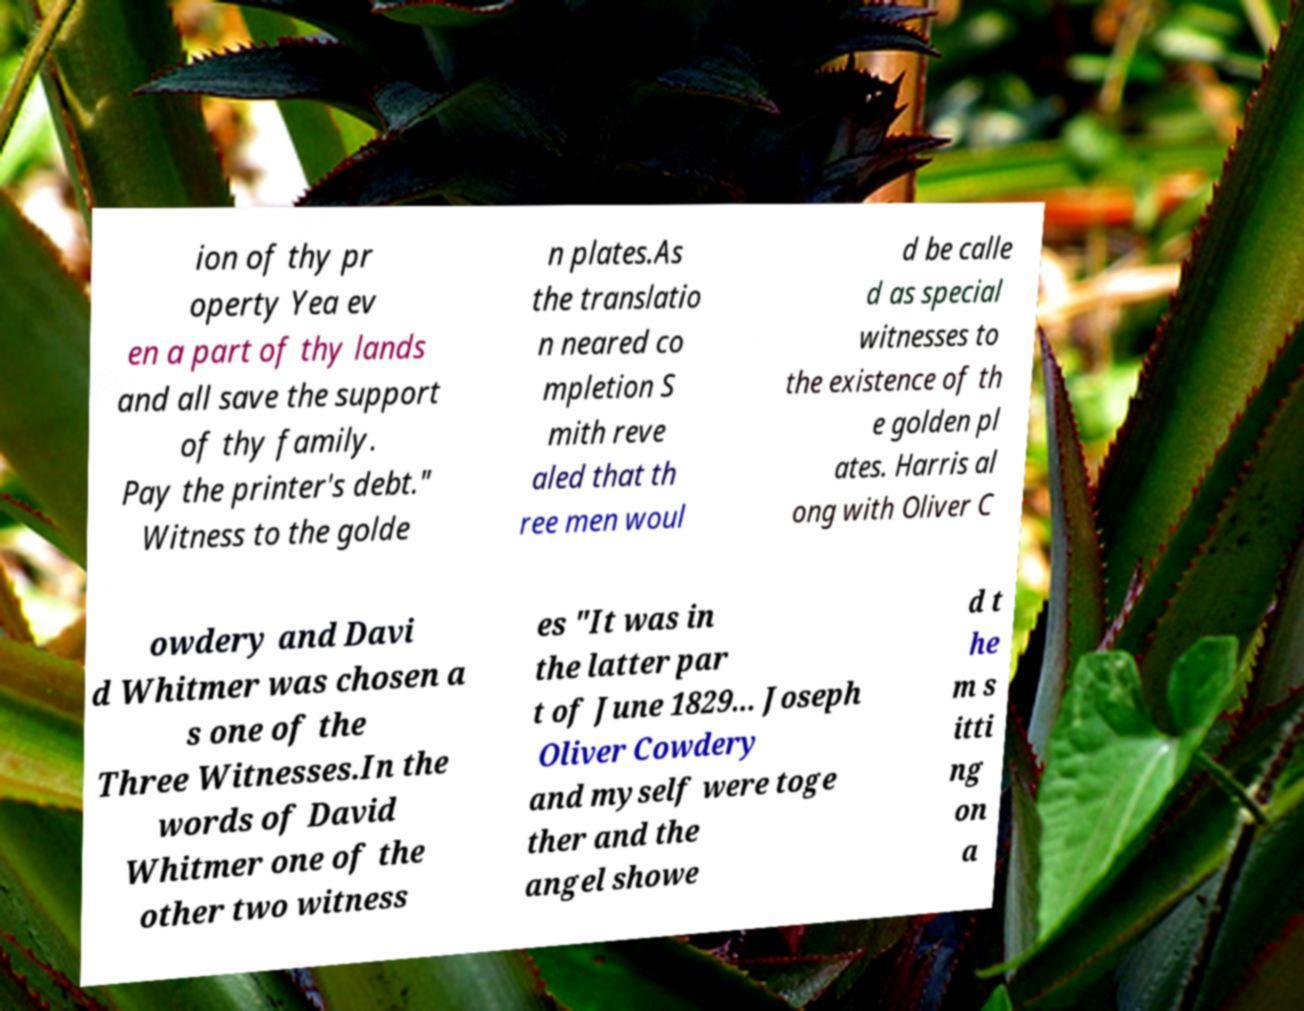Could you assist in decoding the text presented in this image and type it out clearly? ion of thy pr operty Yea ev en a part of thy lands and all save the support of thy family. Pay the printer's debt." Witness to the golde n plates.As the translatio n neared co mpletion S mith reve aled that th ree men woul d be calle d as special witnesses to the existence of th e golden pl ates. Harris al ong with Oliver C owdery and Davi d Whitmer was chosen a s one of the Three Witnesses.In the words of David Whitmer one of the other two witness es "It was in the latter par t of June 1829... Joseph Oliver Cowdery and myself were toge ther and the angel showe d t he m s itti ng on a 